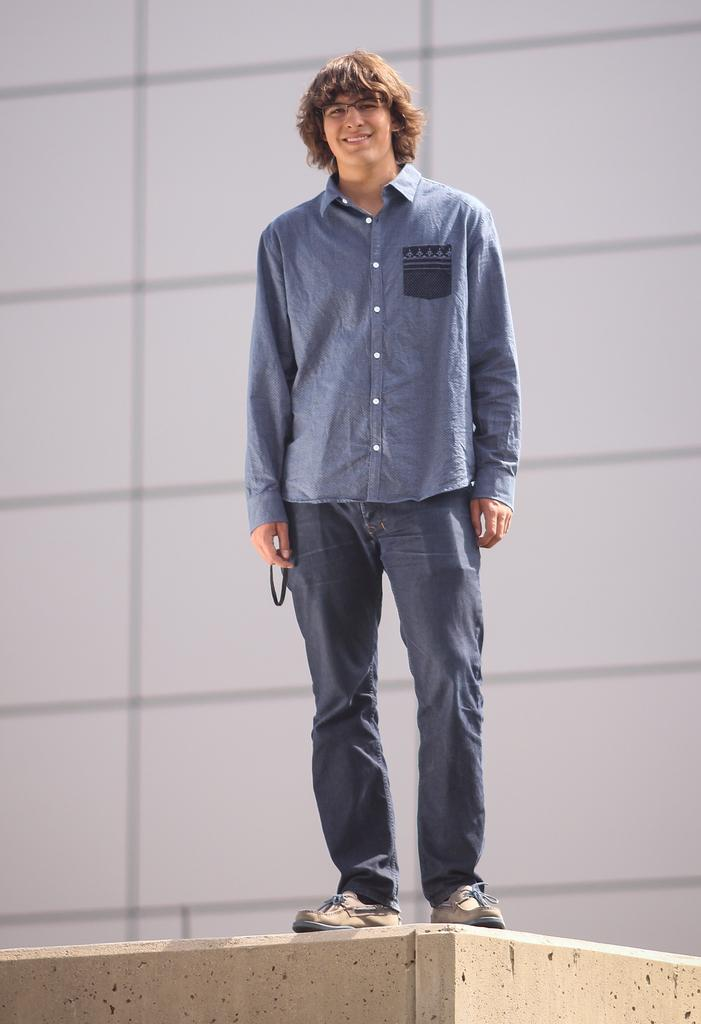Who or what is the main subject in the center of the image? There is a person in the center of the image. What is the person doing in the image? The person is standing on a wall. What else can be seen in the background of the image? There is a wall in the background of the image. What type of chin is visible on the person in the image? There is no chin visible on the person in the image, as the person is likely facing away from the camera or their face is not visible. 